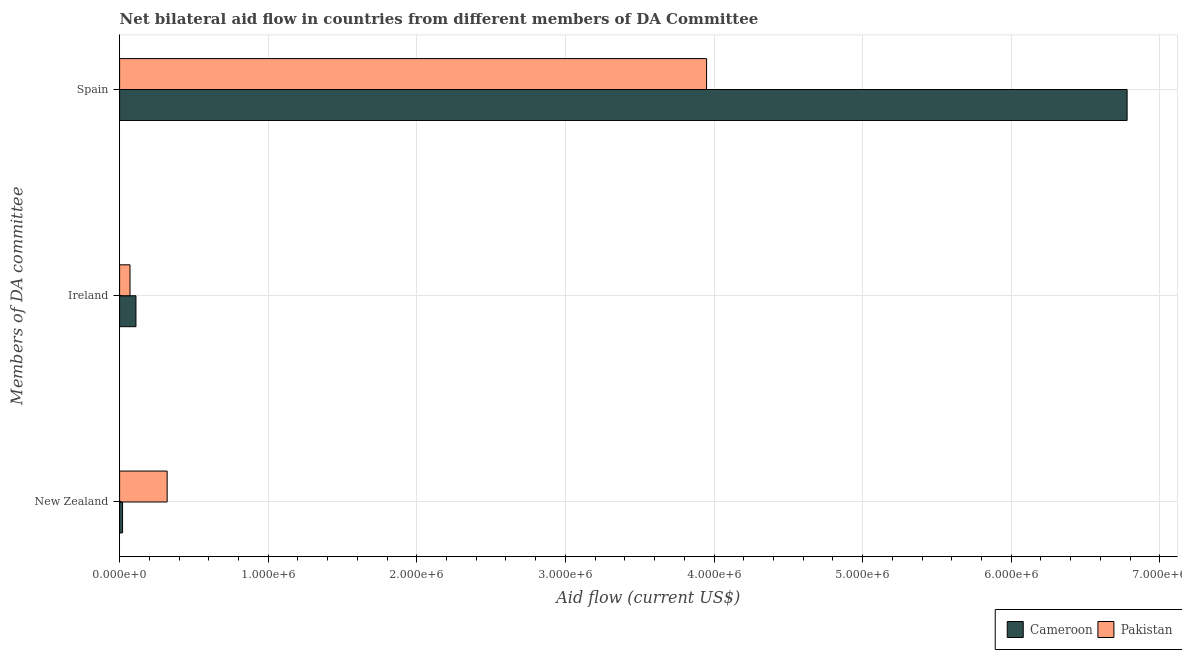How many different coloured bars are there?
Your answer should be compact. 2. How many groups of bars are there?
Provide a short and direct response. 3. Are the number of bars per tick equal to the number of legend labels?
Provide a succinct answer. Yes. What is the amount of aid provided by ireland in Cameroon?
Your answer should be very brief. 1.10e+05. Across all countries, what is the maximum amount of aid provided by ireland?
Provide a succinct answer. 1.10e+05. Across all countries, what is the minimum amount of aid provided by new zealand?
Offer a very short reply. 2.00e+04. In which country was the amount of aid provided by ireland maximum?
Provide a short and direct response. Cameroon. In which country was the amount of aid provided by new zealand minimum?
Your answer should be very brief. Cameroon. What is the total amount of aid provided by new zealand in the graph?
Make the answer very short. 3.40e+05. What is the difference between the amount of aid provided by ireland in Pakistan and that in Cameroon?
Ensure brevity in your answer.  -4.00e+04. What is the difference between the amount of aid provided by new zealand in Cameroon and the amount of aid provided by spain in Pakistan?
Keep it short and to the point. -3.93e+06. What is the average amount of aid provided by spain per country?
Provide a succinct answer. 5.36e+06. What is the difference between the amount of aid provided by ireland and amount of aid provided by new zealand in Cameroon?
Your answer should be very brief. 9.00e+04. In how many countries, is the amount of aid provided by spain greater than 3000000 US$?
Make the answer very short. 2. What is the ratio of the amount of aid provided by spain in Cameroon to that in Pakistan?
Offer a terse response. 1.72. Is the difference between the amount of aid provided by ireland in Pakistan and Cameroon greater than the difference between the amount of aid provided by spain in Pakistan and Cameroon?
Make the answer very short. Yes. What is the difference between the highest and the second highest amount of aid provided by spain?
Provide a short and direct response. 2.83e+06. What is the difference between the highest and the lowest amount of aid provided by new zealand?
Offer a very short reply. 3.00e+05. What does the 1st bar from the bottom in New Zealand represents?
Keep it short and to the point. Cameroon. Is it the case that in every country, the sum of the amount of aid provided by new zealand and amount of aid provided by ireland is greater than the amount of aid provided by spain?
Make the answer very short. No. How many bars are there?
Your response must be concise. 6. Does the graph contain grids?
Keep it short and to the point. Yes. What is the title of the graph?
Your answer should be very brief. Net bilateral aid flow in countries from different members of DA Committee. What is the label or title of the X-axis?
Offer a very short reply. Aid flow (current US$). What is the label or title of the Y-axis?
Your response must be concise. Members of DA committee. What is the Aid flow (current US$) of Cameroon in Ireland?
Provide a succinct answer. 1.10e+05. What is the Aid flow (current US$) of Pakistan in Ireland?
Provide a succinct answer. 7.00e+04. What is the Aid flow (current US$) in Cameroon in Spain?
Provide a succinct answer. 6.78e+06. What is the Aid flow (current US$) of Pakistan in Spain?
Ensure brevity in your answer.  3.95e+06. Across all Members of DA committee, what is the maximum Aid flow (current US$) of Cameroon?
Your response must be concise. 6.78e+06. Across all Members of DA committee, what is the maximum Aid flow (current US$) of Pakistan?
Ensure brevity in your answer.  3.95e+06. Across all Members of DA committee, what is the minimum Aid flow (current US$) of Cameroon?
Offer a terse response. 2.00e+04. Across all Members of DA committee, what is the minimum Aid flow (current US$) in Pakistan?
Your response must be concise. 7.00e+04. What is the total Aid flow (current US$) in Cameroon in the graph?
Your response must be concise. 6.91e+06. What is the total Aid flow (current US$) of Pakistan in the graph?
Your answer should be very brief. 4.34e+06. What is the difference between the Aid flow (current US$) of Cameroon in New Zealand and that in Ireland?
Your response must be concise. -9.00e+04. What is the difference between the Aid flow (current US$) of Cameroon in New Zealand and that in Spain?
Your answer should be very brief. -6.76e+06. What is the difference between the Aid flow (current US$) in Pakistan in New Zealand and that in Spain?
Make the answer very short. -3.63e+06. What is the difference between the Aid flow (current US$) in Cameroon in Ireland and that in Spain?
Give a very brief answer. -6.67e+06. What is the difference between the Aid flow (current US$) of Pakistan in Ireland and that in Spain?
Your answer should be very brief. -3.88e+06. What is the difference between the Aid flow (current US$) in Cameroon in New Zealand and the Aid flow (current US$) in Pakistan in Spain?
Offer a terse response. -3.93e+06. What is the difference between the Aid flow (current US$) in Cameroon in Ireland and the Aid flow (current US$) in Pakistan in Spain?
Give a very brief answer. -3.84e+06. What is the average Aid flow (current US$) in Cameroon per Members of DA committee?
Give a very brief answer. 2.30e+06. What is the average Aid flow (current US$) in Pakistan per Members of DA committee?
Your answer should be compact. 1.45e+06. What is the difference between the Aid flow (current US$) in Cameroon and Aid flow (current US$) in Pakistan in New Zealand?
Ensure brevity in your answer.  -3.00e+05. What is the difference between the Aid flow (current US$) in Cameroon and Aid flow (current US$) in Pakistan in Ireland?
Make the answer very short. 4.00e+04. What is the difference between the Aid flow (current US$) in Cameroon and Aid flow (current US$) in Pakistan in Spain?
Provide a succinct answer. 2.83e+06. What is the ratio of the Aid flow (current US$) in Cameroon in New Zealand to that in Ireland?
Provide a short and direct response. 0.18. What is the ratio of the Aid flow (current US$) in Pakistan in New Zealand to that in Ireland?
Give a very brief answer. 4.57. What is the ratio of the Aid flow (current US$) in Cameroon in New Zealand to that in Spain?
Offer a very short reply. 0. What is the ratio of the Aid flow (current US$) of Pakistan in New Zealand to that in Spain?
Offer a very short reply. 0.08. What is the ratio of the Aid flow (current US$) of Cameroon in Ireland to that in Spain?
Offer a very short reply. 0.02. What is the ratio of the Aid flow (current US$) in Pakistan in Ireland to that in Spain?
Give a very brief answer. 0.02. What is the difference between the highest and the second highest Aid flow (current US$) of Cameroon?
Your answer should be compact. 6.67e+06. What is the difference between the highest and the second highest Aid flow (current US$) in Pakistan?
Offer a very short reply. 3.63e+06. What is the difference between the highest and the lowest Aid flow (current US$) in Cameroon?
Keep it short and to the point. 6.76e+06. What is the difference between the highest and the lowest Aid flow (current US$) of Pakistan?
Offer a terse response. 3.88e+06. 